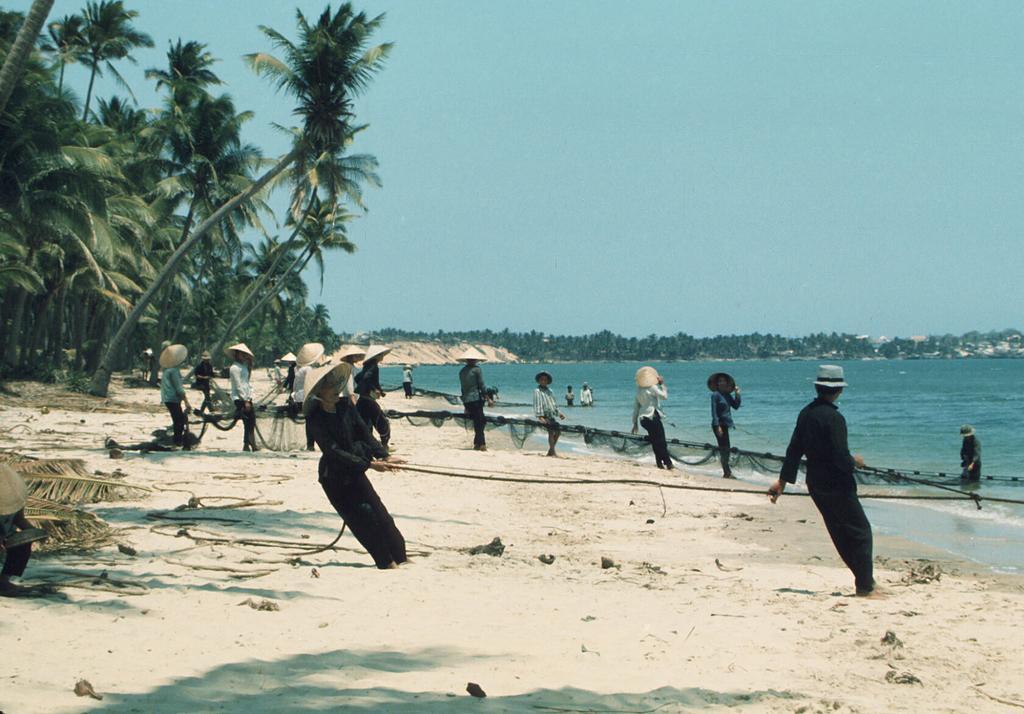Could you give a brief overview of what you see in this image? In the picture we can see a beach with sand and water, which is blue in color and on the sand surface, we can see some people are standing wearing a hat and in the background we can see a tree and sky. 